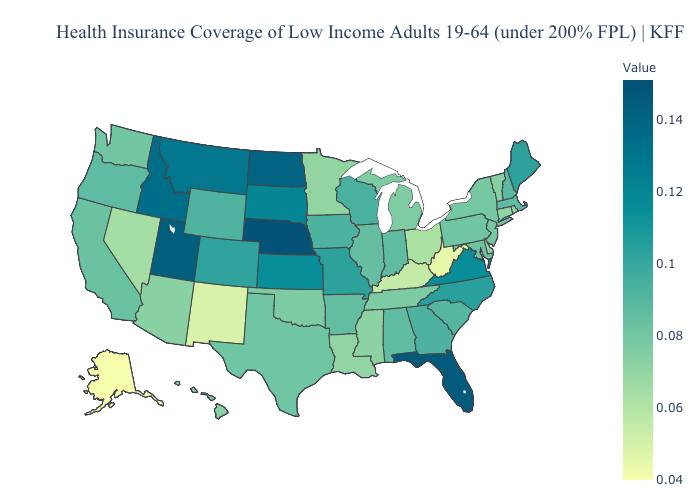Does Maine have the highest value in the Northeast?
Short answer required. Yes. Which states have the lowest value in the USA?
Give a very brief answer. Alaska. Does Nebraska have the highest value in the USA?
Answer briefly. Yes. Does Connecticut have a higher value than Alaska?
Answer briefly. Yes. 